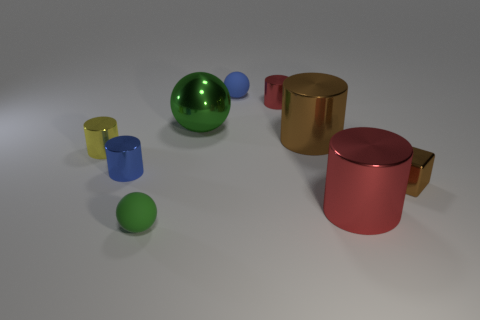Are there any small yellow matte things that have the same shape as the large red shiny thing?
Your response must be concise. No. Is the material of the block the same as the blue thing that is behind the small yellow cylinder?
Your answer should be very brief. No. What material is the small object right of the red cylinder in front of the yellow shiny cylinder?
Provide a short and direct response. Metal. Is the number of blue cylinders that are in front of the tiny blue rubber thing greater than the number of big gray objects?
Give a very brief answer. Yes. Is there a metal object?
Your answer should be very brief. Yes. There is a large metal object that is in front of the yellow metal cylinder; what color is it?
Offer a terse response. Red. What is the material of the brown cylinder that is the same size as the green metal ball?
Give a very brief answer. Metal. How many other things are there of the same material as the large brown object?
Ensure brevity in your answer.  6. The sphere that is both behind the small green sphere and in front of the small red cylinder is what color?
Your answer should be very brief. Green. What number of things are red cylinders that are in front of the large green metallic sphere or big red objects?
Your answer should be very brief. 1. 